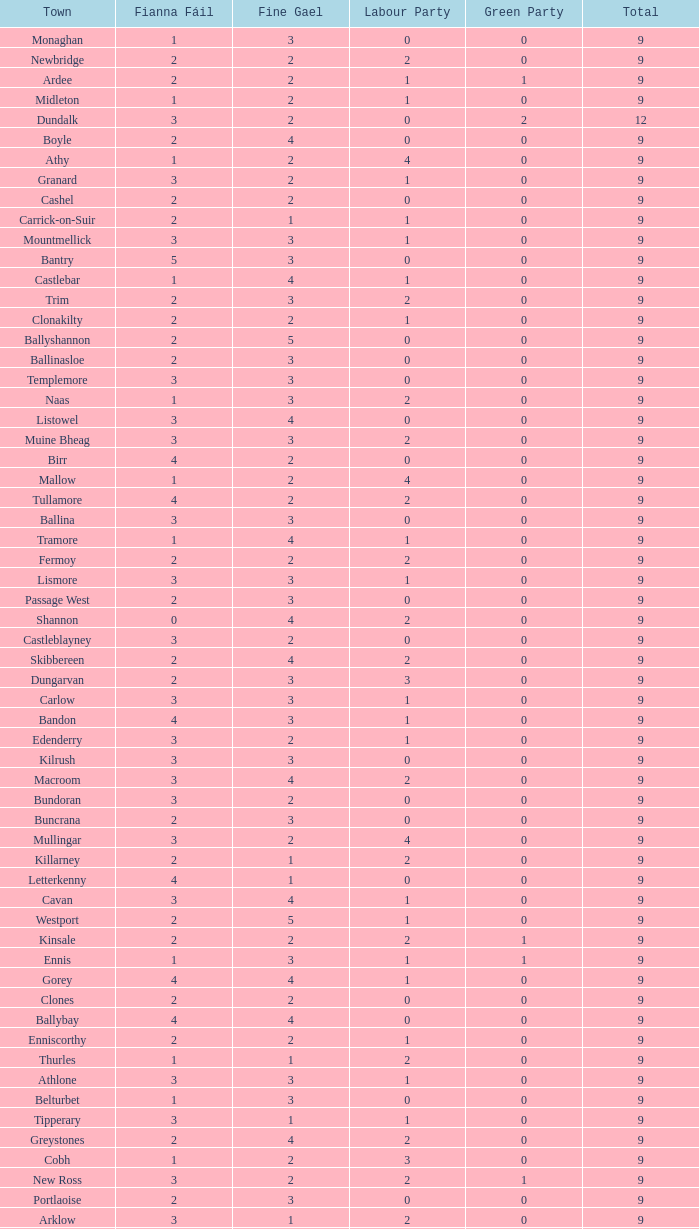Could you parse the entire table as a dict? {'header': ['Town', 'Fianna Fáil', 'Fine Gael', 'Labour Party', 'Green Party', 'Total'], 'rows': [['Monaghan', '1', '3', '0', '0', '9'], ['Newbridge', '2', '2', '2', '0', '9'], ['Ardee', '2', '2', '1', '1', '9'], ['Midleton', '1', '2', '1', '0', '9'], ['Dundalk', '3', '2', '0', '2', '12'], ['Boyle', '2', '4', '0', '0', '9'], ['Athy', '1', '2', '4', '0', '9'], ['Granard', '3', '2', '1', '0', '9'], ['Cashel', '2', '2', '0', '0', '9'], ['Carrick-on-Suir', '2', '1', '1', '0', '9'], ['Mountmellick', '3', '3', '1', '0', '9'], ['Bantry', '5', '3', '0', '0', '9'], ['Castlebar', '1', '4', '1', '0', '9'], ['Trim', '2', '3', '2', '0', '9'], ['Clonakilty', '2', '2', '1', '0', '9'], ['Ballyshannon', '2', '5', '0', '0', '9'], ['Ballinasloe', '2', '3', '0', '0', '9'], ['Templemore', '3', '3', '0', '0', '9'], ['Naas', '1', '3', '2', '0', '9'], ['Listowel', '3', '4', '0', '0', '9'], ['Muine Bheag', '3', '3', '2', '0', '9'], ['Birr', '4', '2', '0', '0', '9'], ['Mallow', '1', '2', '4', '0', '9'], ['Tullamore', '4', '2', '2', '0', '9'], ['Ballina', '3', '3', '0', '0', '9'], ['Tramore', '1', '4', '1', '0', '9'], ['Fermoy', '2', '2', '2', '0', '9'], ['Lismore', '3', '3', '1', '0', '9'], ['Passage West', '2', '3', '0', '0', '9'], ['Shannon', '0', '4', '2', '0', '9'], ['Castleblayney', '3', '2', '0', '0', '9'], ['Skibbereen', '2', '4', '2', '0', '9'], ['Dungarvan', '2', '3', '3', '0', '9'], ['Carlow', '3', '3', '1', '0', '9'], ['Bandon', '4', '3', '1', '0', '9'], ['Edenderry', '3', '2', '1', '0', '9'], ['Kilrush', '3', '3', '0', '0', '9'], ['Macroom', '3', '4', '2', '0', '9'], ['Bundoran', '3', '2', '0', '0', '9'], ['Buncrana', '2', '3', '0', '0', '9'], ['Mullingar', '3', '2', '4', '0', '9'], ['Killarney', '2', '1', '2', '0', '9'], ['Letterkenny', '4', '1', '0', '0', '9'], ['Cavan', '3', '4', '1', '0', '9'], ['Westport', '2', '5', '1', '0', '9'], ['Kinsale', '2', '2', '2', '1', '9'], ['Ennis', '1', '3', '1', '1', '9'], ['Gorey', '4', '4', '1', '0', '9'], ['Clones', '2', '2', '0', '0', '9'], ['Ballybay', '4', '4', '0', '0', '9'], ['Enniscorthy', '2', '2', '1', '0', '9'], ['Thurles', '1', '1', '2', '0', '9'], ['Athlone', '3', '3', '1', '0', '9'], ['Belturbet', '1', '3', '0', '0', '9'], ['Tipperary', '3', '1', '1', '0', '9'], ['Greystones', '2', '4', '2', '0', '9'], ['Cobh', '1', '2', '3', '0', '9'], ['New Ross', '3', '2', '2', '1', '9'], ['Portlaoise', '2', '3', '0', '0', '9'], ['Arklow', '3', '1', '2', '0', '9'], ['Cootehill', '3', '3', '0', '0', '9'], ['Longford', '2', '3', '0', '0', '9'], ['Balbriggan', '1', '1', '3', '1', '9'], ['Youghal', '3', '2', '1', '1', '9'], ['Tuam', '3', '2', '2', '0', '9'], ['Bray', '2', '3', '3', '1', '12'], ['Wicklow', '1', '3', '1', '1', '9'], ['Loughrea', '3', '2', '0', '0', '9'], ['Carrickmacross', '2', '3', '0', '2', '9'], ['Kells', '3', '2', '2', '0', '9'], ['Nenagh', '2', '2', '2', '0', '9'], ['Leixlip', '1', '3', '2', '1', '9'], ['Kilkee', '4', '4', '0', '0', '9'], ['Tralee', '2', '3', '3', '0', '12'], ['Navan', '4', '2', '0', '0', '9']]} What is the lowest number in the Labour Party for the Fianna Fail higher than 5? None. 